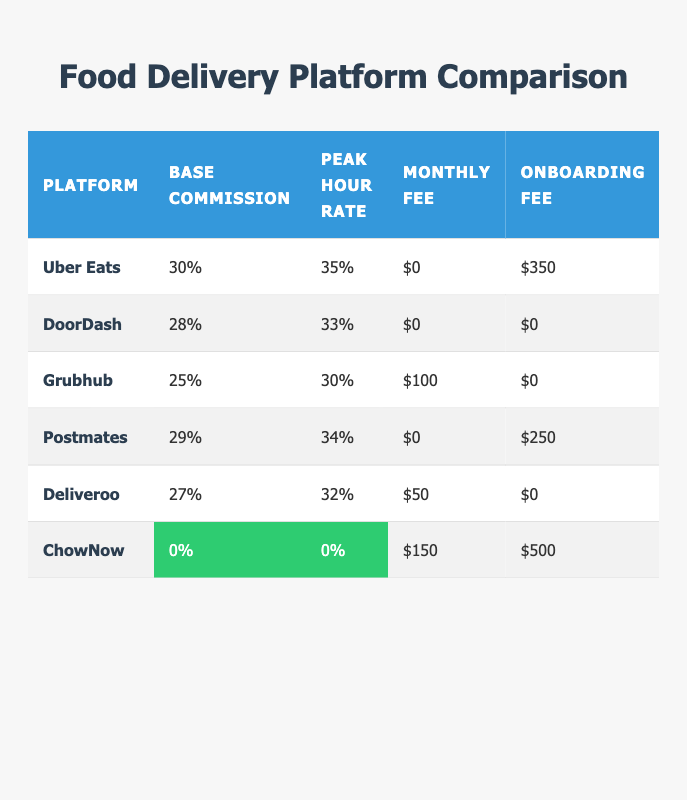What is the base commission rate for Uber Eats? The table lists the base commission rate for Uber Eats as 30%.
Answer: 30% Which platform has the highest average order value? According to the table, ChowNow has the highest average order value at $40.
Answer: $40 Is there a platform that charges a zero percent base commission rate? Yes, the table shows that ChowNow charges a base commission rate of 0%.
Answer: Yes What is the difference in peak hour rates between DoorDash and Grubhub? The peak hour rate for DoorDash is 33% and for Grubhub, it is 30%. The difference is 33% - 30% = 3%.
Answer: 3% Which platforms provide 24/7 restaurant support? The table indicates that Uber Eats and Deliveroo offer 24/7 restaurant support.
Answer: Uber Eats and Deliveroo If a restaurant averages $50 in orders, how much would they pay in commission to Uber Eats during peak hours? The peak hour commission for Uber Eats is 35%. Thus, for a $50 order, the commission would be 50 * 0.35 = $17.50.
Answer: $17.50 Which platform has the lowest monthly fee and what is the amount? The table shows that both Uber Eats and DoorDash have a monthly fee of $0, which makes them the lowest.
Answer: $0 What is the average base commission rate across all platforms? To find the average, sum the base rates: (30 + 28 + 25 + 29 + 27 + 0) = 139 and divide by 6 platforms, which gives 139 / 6 = 23.17%.
Answer: 23.17% Does Deliveroo have a higher peak hour rate than Postmates? Yes, Deliveroo's peak hour rate is 32% which is higher than Postmates' peak hour rate of 34%.
Answer: No 